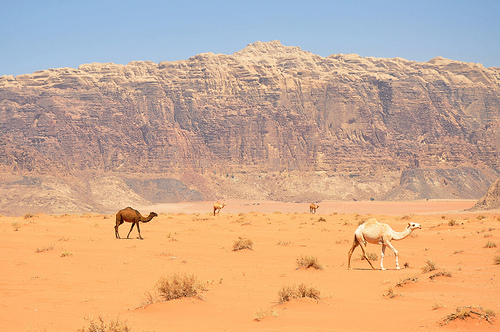<image>
Is there a camel on the sand? Yes. Looking at the image, I can see the camel is positioned on top of the sand, with the sand providing support. 